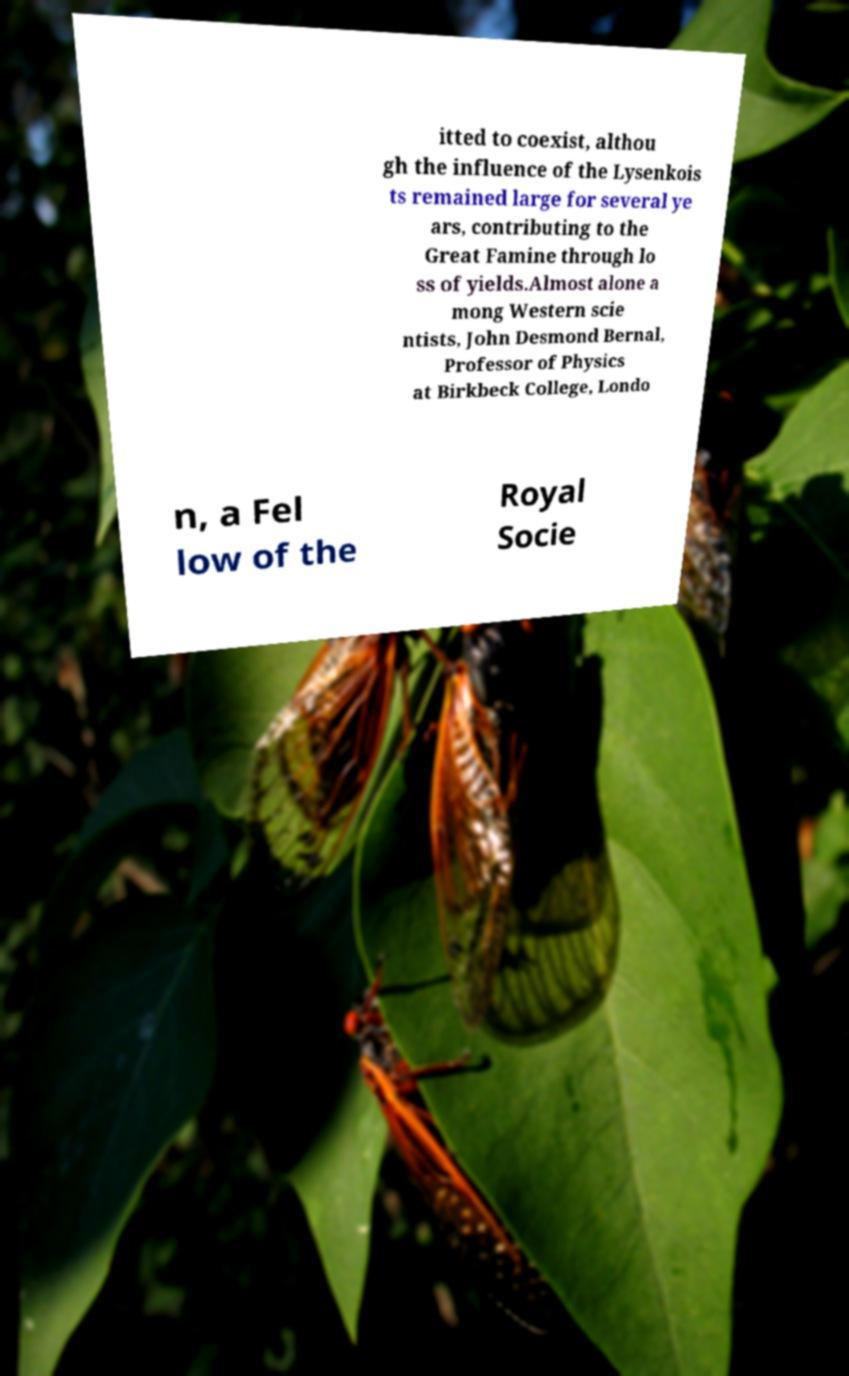Can you accurately transcribe the text from the provided image for me? itted to coexist, althou gh the influence of the Lysenkois ts remained large for several ye ars, contributing to the Great Famine through lo ss of yields.Almost alone a mong Western scie ntists, John Desmond Bernal, Professor of Physics at Birkbeck College, Londo n, a Fel low of the Royal Socie 